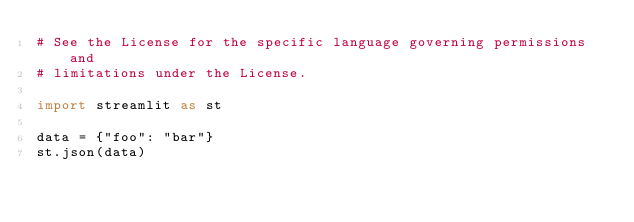<code> <loc_0><loc_0><loc_500><loc_500><_Python_># See the License for the specific language governing permissions and
# limitations under the License.

import streamlit as st

data = {"foo": "bar"}
st.json(data)
</code> 